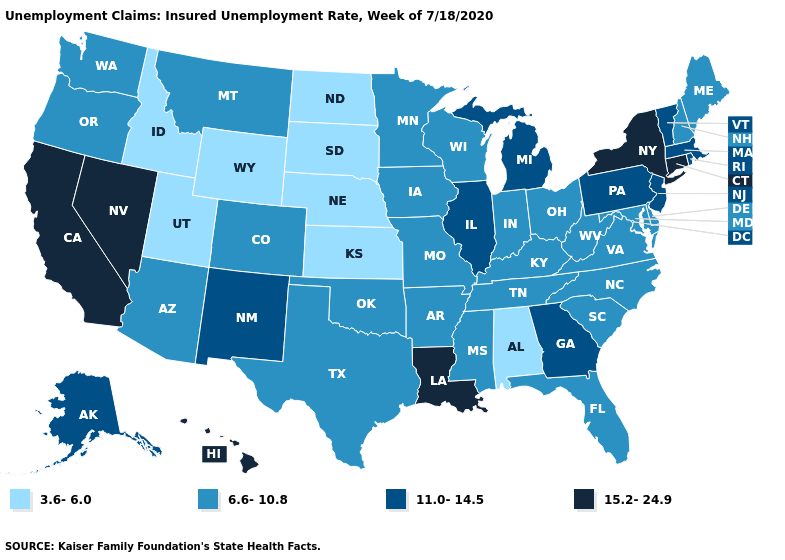Does the first symbol in the legend represent the smallest category?
Answer briefly. Yes. What is the highest value in the USA?
Be succinct. 15.2-24.9. What is the value of New York?
Write a very short answer. 15.2-24.9. Name the states that have a value in the range 15.2-24.9?
Keep it brief. California, Connecticut, Hawaii, Louisiana, Nevada, New York. Which states hav the highest value in the MidWest?
Write a very short answer. Illinois, Michigan. Does the map have missing data?
Give a very brief answer. No. Among the states that border Rhode Island , does Connecticut have the lowest value?
Quick response, please. No. Does Maryland have the same value as Arkansas?
Be succinct. Yes. What is the value of Georgia?
Be succinct. 11.0-14.5. Name the states that have a value in the range 3.6-6.0?
Quick response, please. Alabama, Idaho, Kansas, Nebraska, North Dakota, South Dakota, Utah, Wyoming. What is the lowest value in the MidWest?
Write a very short answer. 3.6-6.0. Among the states that border Iowa , which have the lowest value?
Keep it brief. Nebraska, South Dakota. What is the value of Maryland?
Write a very short answer. 6.6-10.8. Name the states that have a value in the range 15.2-24.9?
Short answer required. California, Connecticut, Hawaii, Louisiana, Nevada, New York. 